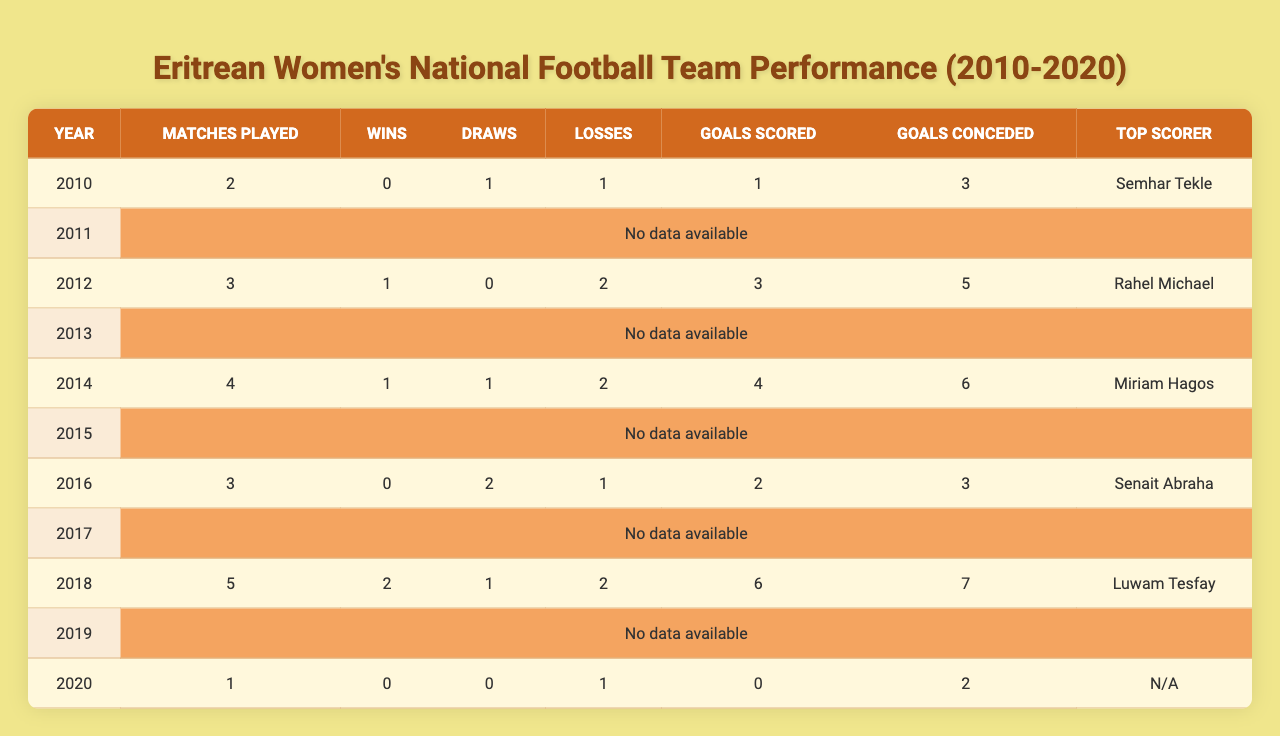What was the total number of matches played by the Eritrean women's national football team between 2010 and 2020? By summing the matches played across the years, we have 2 (2010) + 3 (2012) + 4 (2014) + 3 (2016) + 5 (2018) + 1 (2020) = 18 matches played in total.
Answer: 18 In which year did the team record their highest number of wins? The most wins recorded in the table are 2 wins in 2018, as that is the only year where the count is higher than other years.
Answer: 2018 How many draws did Eritrean women’s national football team achieve across all years? Adding the draws together gives us 1 (2010) + 0 (2012) + 1 (2014) + 2 (2016) + 1 (2018) + 0 (2020) = 5 draws in total across all years.
Answer: 5 What was the overall goal difference (goals scored minus goals conceded) for the team in 2014? In 2014, the team scored 4 goals and conceded 6 goals, resulting in a goal difference of 4 - 6 = -2.
Answer: -2 Which year had the top scorer, and who was it? The top scorer for 2018 was Luwam Tesfay, which is indicated in the table as the highest scorer for that year.
Answer: 2018, Luwam Tesfay Did the team ever achieve more wins than losses in any given year? Looking at the wins and losses for each year, the only year with more wins than losses is 2018 (2 wins and 2 losses), which does not meet the criteria. Therefore, the answer is no.
Answer: No What is the average number of goals scored by the team per match from 2010 to 2020? Calculating the average, we have total goals scored as 1 (2010) + 3 (2012) + 4 (2014) + 2 (2016) + 6 (2018) + 0 (2020) = 16 goals. The average per match is therefore 16 total goals divided by 18 total matches = approximately 0.89 goals per match.
Answer: 0.89 How many years did the team have zero wins? According to the data, the team had zero wins in 2010, 2016, and 2020, which accounts for three years with no wins.
Answer: 3 What was the highest number of goals conceded in a single year? By examining each year, the highest goals conceded were 7 goals in 2018.
Answer: 7 Was there any year where the team had more draws than losses? Analyzing each year shows that in 2016, there were 2 draws and 1 loss, thus indicating that there was indeed a year with more draws than losses.
Answer: Yes 